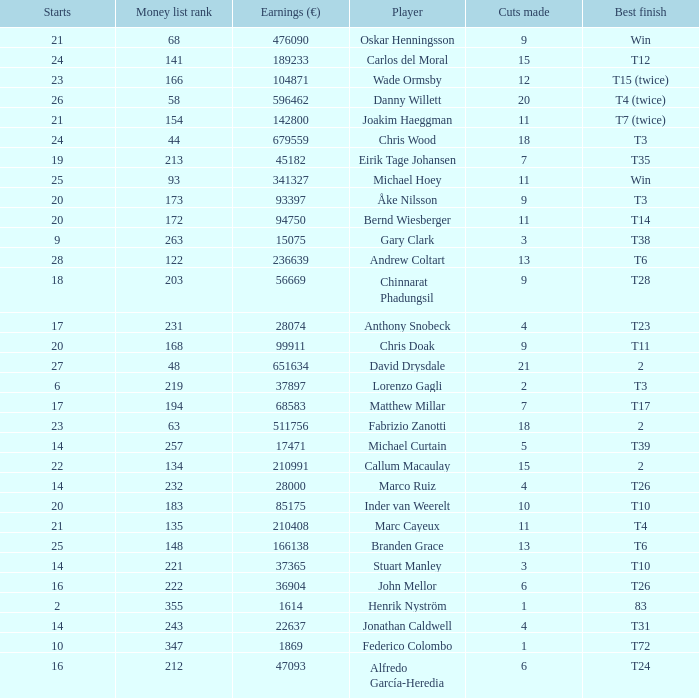How many cuts did Gary Clark make? 3.0. 